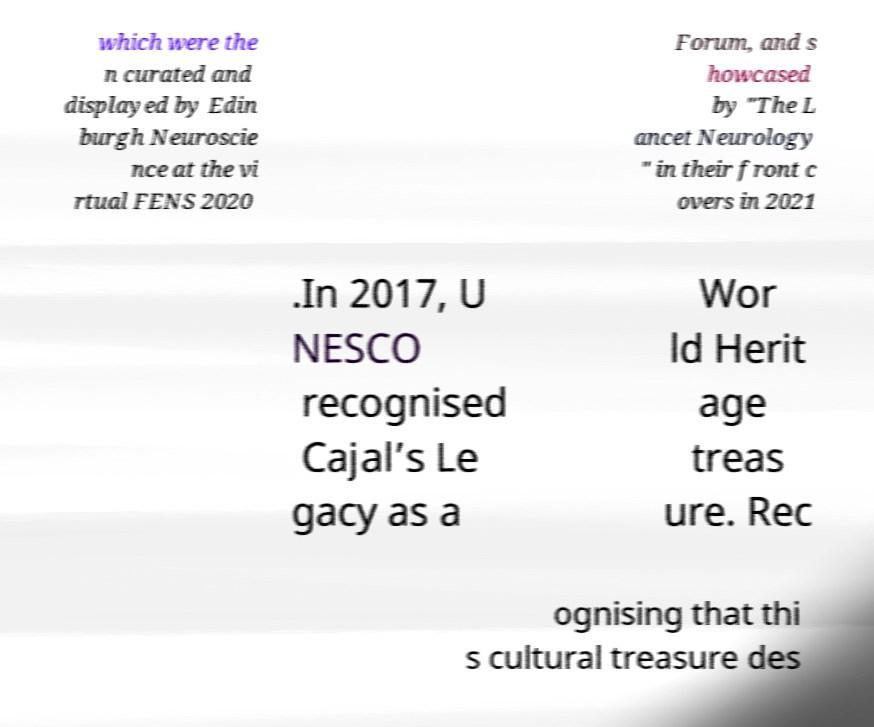Can you read and provide the text displayed in the image?This photo seems to have some interesting text. Can you extract and type it out for me? which were the n curated and displayed by Edin burgh Neuroscie nce at the vi rtual FENS 2020 Forum, and s howcased by "The L ancet Neurology " in their front c overs in 2021 .In 2017, U NESCO recognised Cajal’s Le gacy as a Wor ld Herit age treas ure. Rec ognising that thi s cultural treasure des 